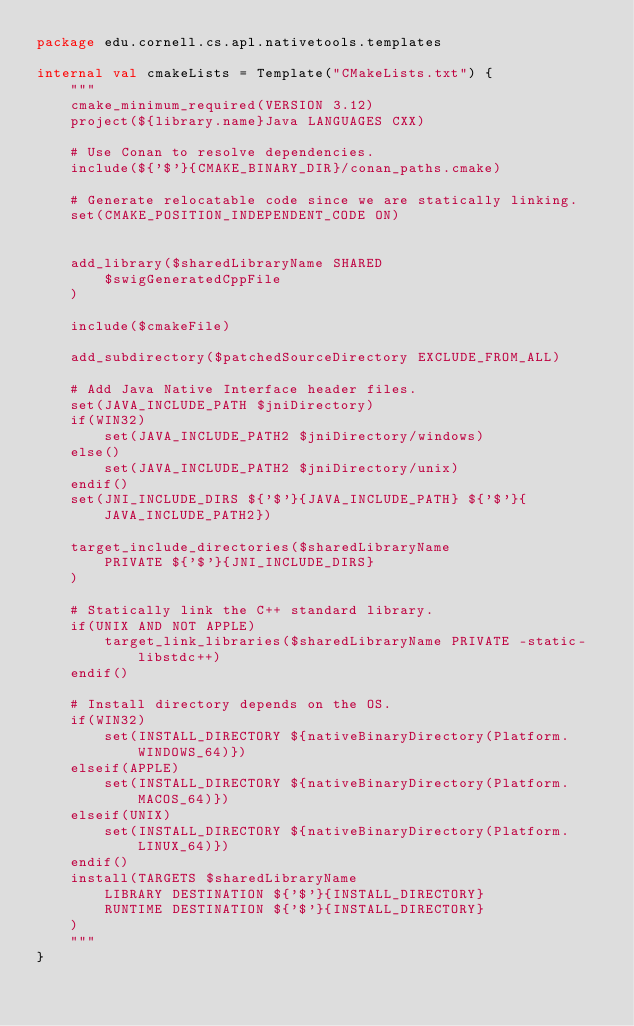<code> <loc_0><loc_0><loc_500><loc_500><_Kotlin_>package edu.cornell.cs.apl.nativetools.templates

internal val cmakeLists = Template("CMakeLists.txt") {
    """
    cmake_minimum_required(VERSION 3.12)
    project(${library.name}Java LANGUAGES CXX)

    # Use Conan to resolve dependencies.
    include(${'$'}{CMAKE_BINARY_DIR}/conan_paths.cmake)

    # Generate relocatable code since we are statically linking.
    set(CMAKE_POSITION_INDEPENDENT_CODE ON)


    add_library($sharedLibraryName SHARED
        $swigGeneratedCppFile
    )

    include($cmakeFile)

    add_subdirectory($patchedSourceDirectory EXCLUDE_FROM_ALL)

    # Add Java Native Interface header files.
    set(JAVA_INCLUDE_PATH $jniDirectory)
    if(WIN32)
        set(JAVA_INCLUDE_PATH2 $jniDirectory/windows)
    else()
        set(JAVA_INCLUDE_PATH2 $jniDirectory/unix)
    endif()
    set(JNI_INCLUDE_DIRS ${'$'}{JAVA_INCLUDE_PATH} ${'$'}{JAVA_INCLUDE_PATH2})

    target_include_directories($sharedLibraryName
        PRIVATE ${'$'}{JNI_INCLUDE_DIRS}
    )

    # Statically link the C++ standard library.
    if(UNIX AND NOT APPLE)
        target_link_libraries($sharedLibraryName PRIVATE -static-libstdc++)
    endif()

    # Install directory depends on the OS.
    if(WIN32)
        set(INSTALL_DIRECTORY ${nativeBinaryDirectory(Platform.WINDOWS_64)})
    elseif(APPLE)
        set(INSTALL_DIRECTORY ${nativeBinaryDirectory(Platform.MACOS_64)})
    elseif(UNIX)
        set(INSTALL_DIRECTORY ${nativeBinaryDirectory(Platform.LINUX_64)})
    endif()
    install(TARGETS $sharedLibraryName
        LIBRARY DESTINATION ${'$'}{INSTALL_DIRECTORY}
        RUNTIME DESTINATION ${'$'}{INSTALL_DIRECTORY}
    )
    """
}
</code> 